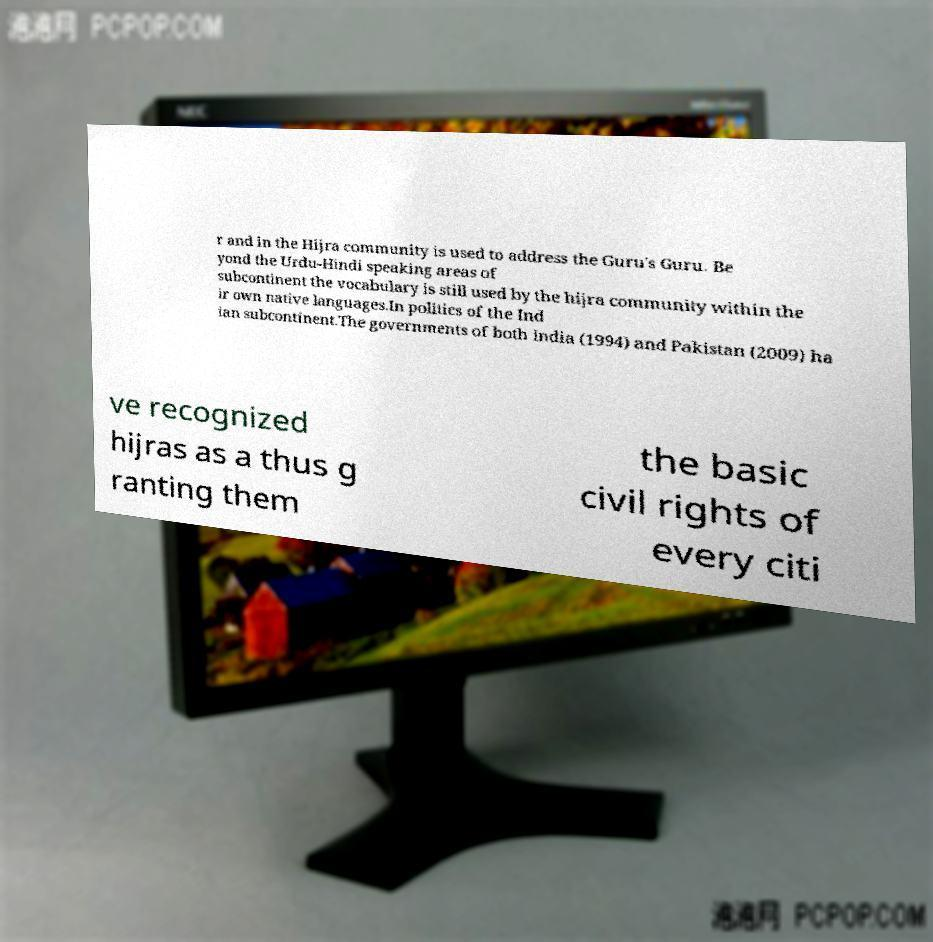What messages or text are displayed in this image? I need them in a readable, typed format. r and in the Hijra community is used to address the Guru's Guru. Be yond the Urdu-Hindi speaking areas of subcontinent the vocabulary is still used by the hijra community within the ir own native languages.In politics of the Ind ian subcontinent.The governments of both India (1994) and Pakistan (2009) ha ve recognized hijras as a thus g ranting them the basic civil rights of every citi 